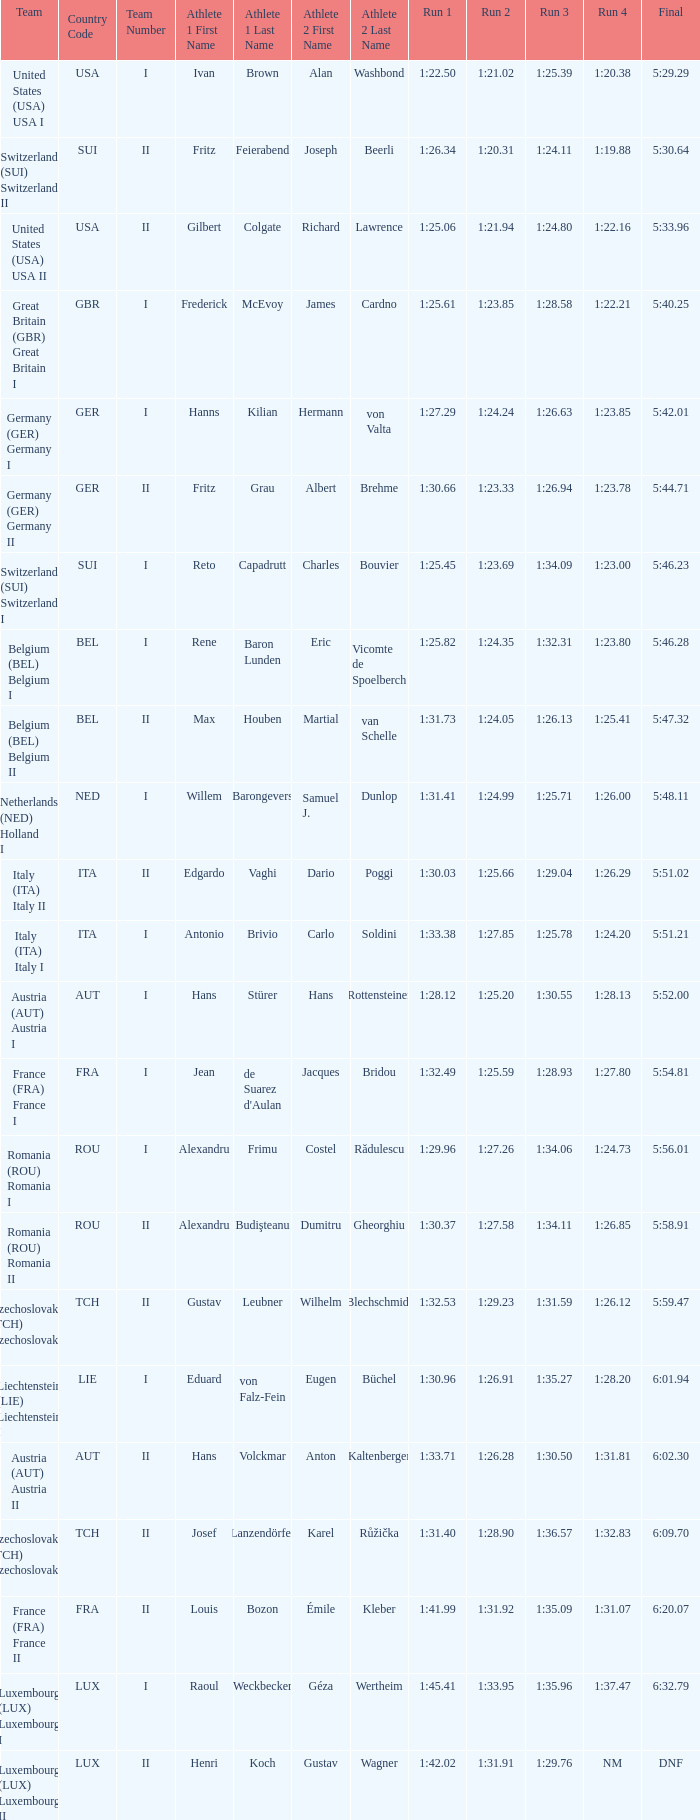For which run 4 does the corresponding run 3 have a time of 1:26.63? 1:23.85. 